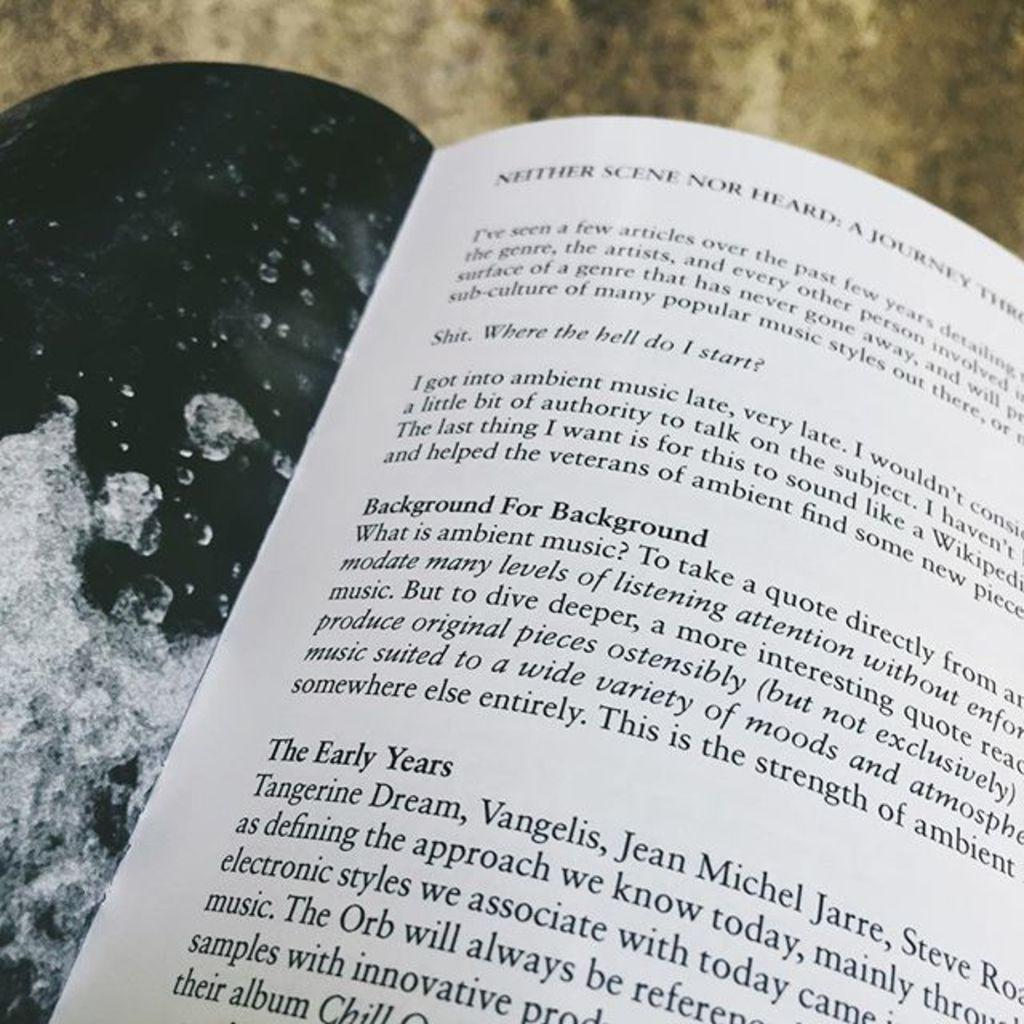Provide a one-sentence caption for the provided image. A book that talks about ambient music is open. 